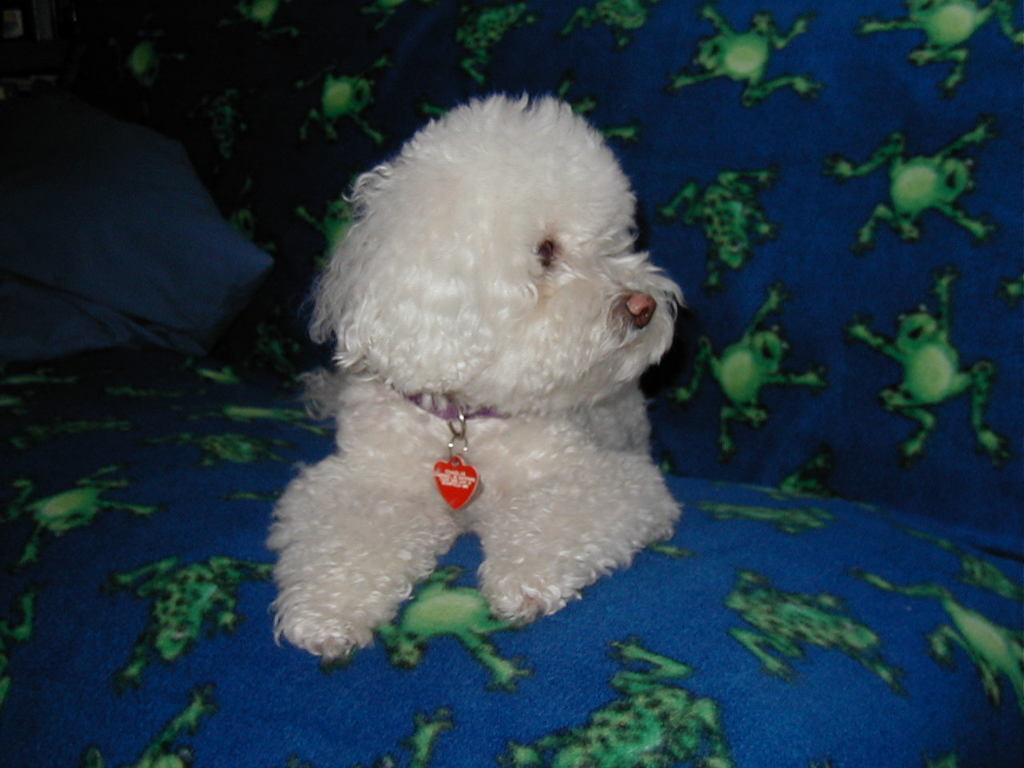What type of animal is in the image? There is a white dog in the image. What accessories is the dog wearing? The dog is wearing a belt and locket. Where is the dog located in the image? The dog is on a sofa. What can be seen on the left side of the image? There is a cloth visible on the left side of the image. How much money is the dog carrying in the image? The dog is not carrying any money in the image. What type of school is visible in the image? There is no school present in the image. 